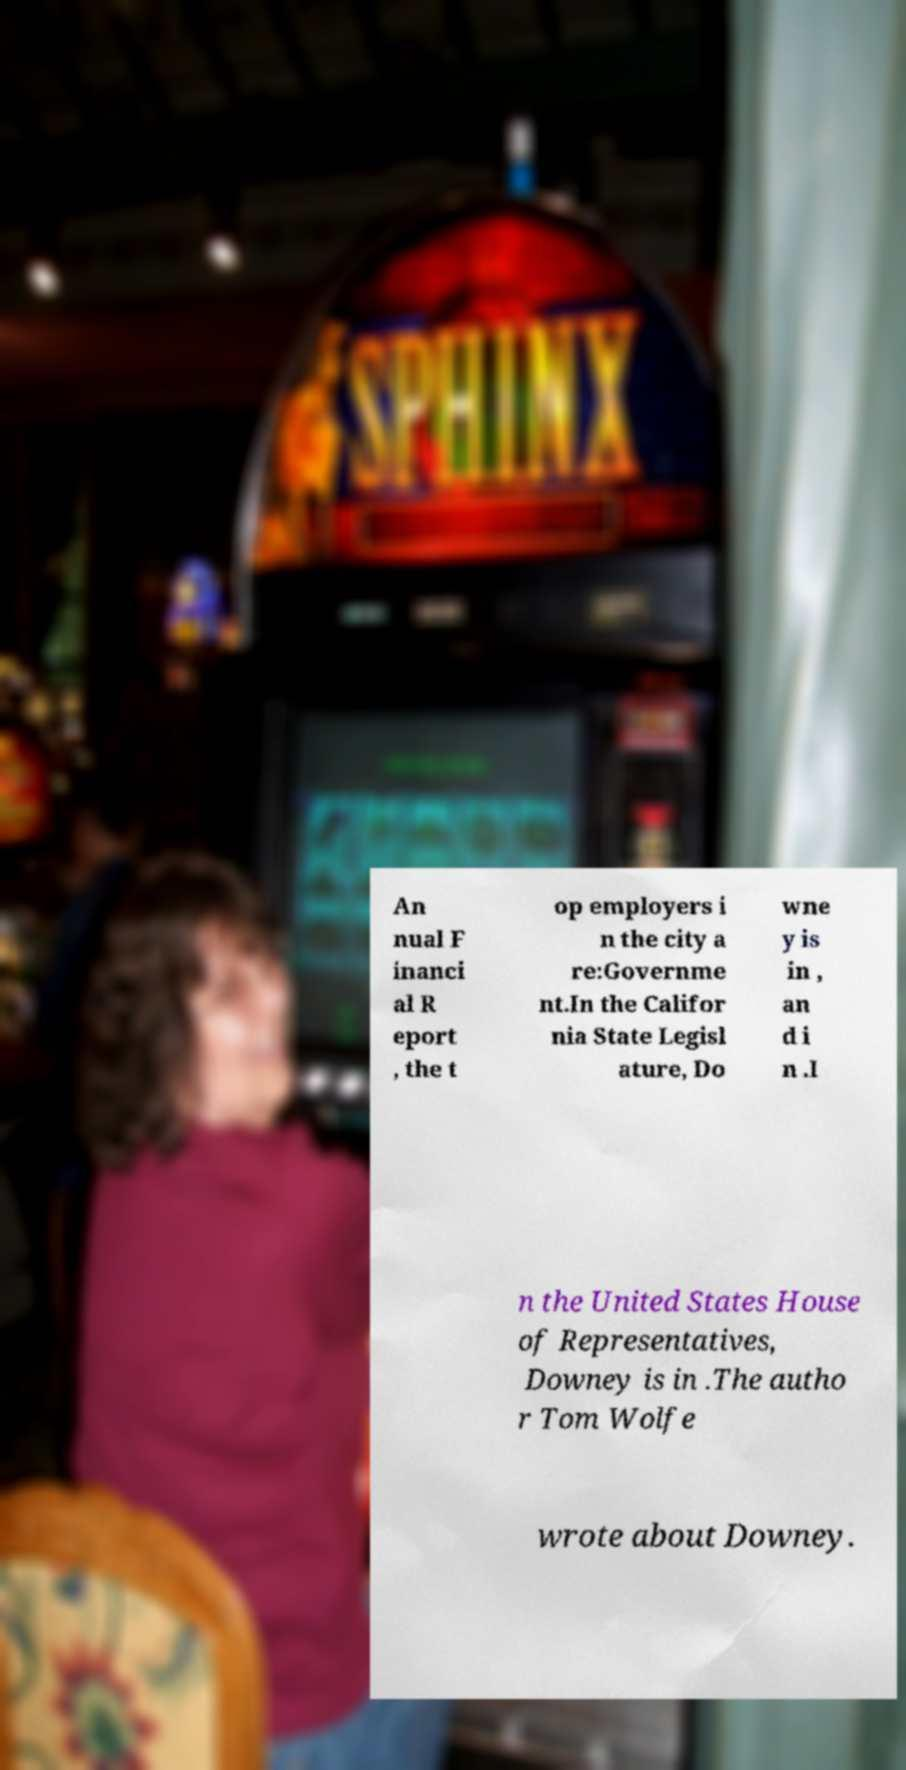What messages or text are displayed in this image? I need them in a readable, typed format. An nual F inanci al R eport , the t op employers i n the city a re:Governme nt.In the Califor nia State Legisl ature, Do wne y is in , an d i n .I n the United States House of Representatives, Downey is in .The autho r Tom Wolfe wrote about Downey. 